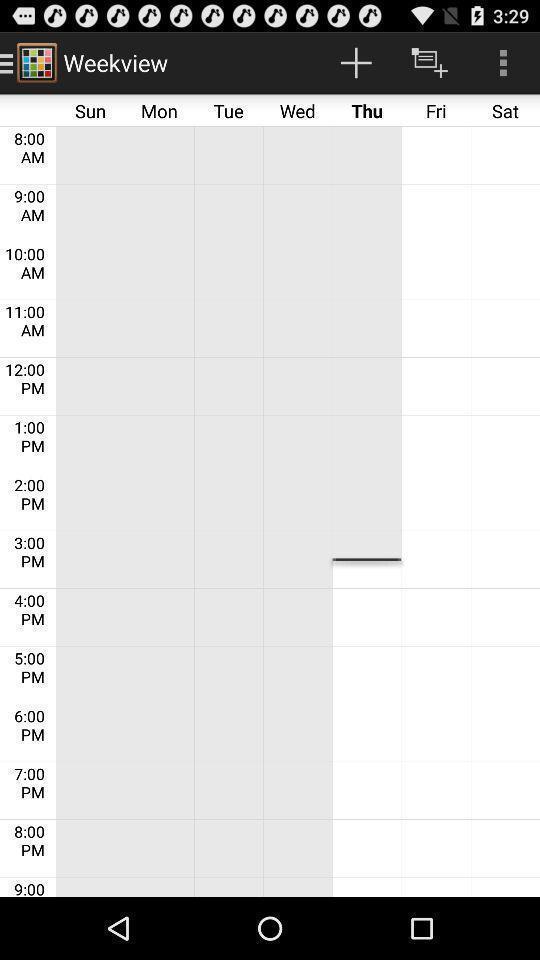What details can you identify in this image? Screen shows week view of time table. 